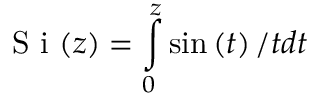<formula> <loc_0><loc_0><loc_500><loc_500>S i ( z ) = \int o p _ { 0 } ^ { z } \sin \left ( t \right ) / t d t</formula> 